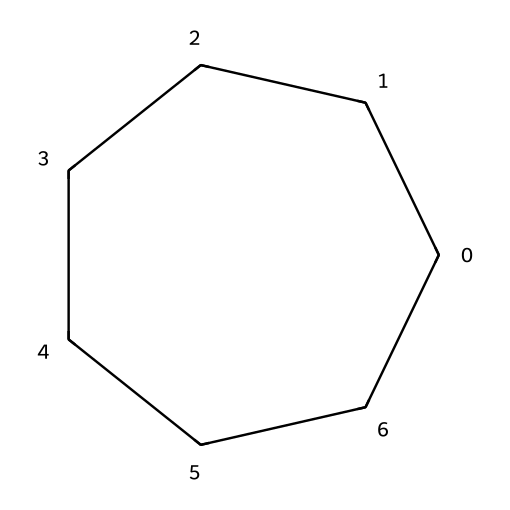What is the name of this chemical? The SMILES representation C1CCCCCC1 indicates a cyclic structure composed of carbon atoms, making this chemical a cycloalkane. Specifically, it features seven carbon atoms arranged in a ring, which is characteristic of cycloheptane.
Answer: cycloheptane How many carbon atoms are in cycloheptane? From the SMILES string C1CCCCCC1, we can observe that there are seven 'C' characters representing carbon atoms in the cyclic structure. Thus, cycloheptane has seven carbon atoms.
Answer: 7 What is the type of bonding present in cycloheptane? The structure shown indicates that cycloheptane is composed entirely of single bonds between the carbon atoms. In a cycloalkane like this, all carbon atoms are sp3 hybridized.
Answer: single bonds How many hydrogen atoms does cycloheptane have? To find the number of hydrogen atoms, we can apply the formula for cycloalkanes: CnH(2n), where n is the number of carbon atoms. Here, n is 7, so 2(7) = 14. Therefore, cycloheptane has 14 hydrogen atoms.
Answer: 14 Is cycloheptane saturated or unsaturated? Cycloheptane, being a cycloalkane with only single bonds between carbon atoms, contains the maximum number of hydrogen atoms for its carbon count. This indicates that it is saturated.
Answer: saturated What type of structure does cycloheptane have? Cycloheptane has a cyclic structure, as indicated by the numbering in the SMILES representation. This means that the atoms are arranged in a closed loop or ring.
Answer: cyclic What is the general formula for cycloalkanes? Cycloalkanes follow a general formula of CnH(2n), which applies to any cyclic hydrocarbon where 'n' refers to the number of carbon atoms. This can be confirmed with our specific example of cycloheptane.
Answer: CnH(2n) 